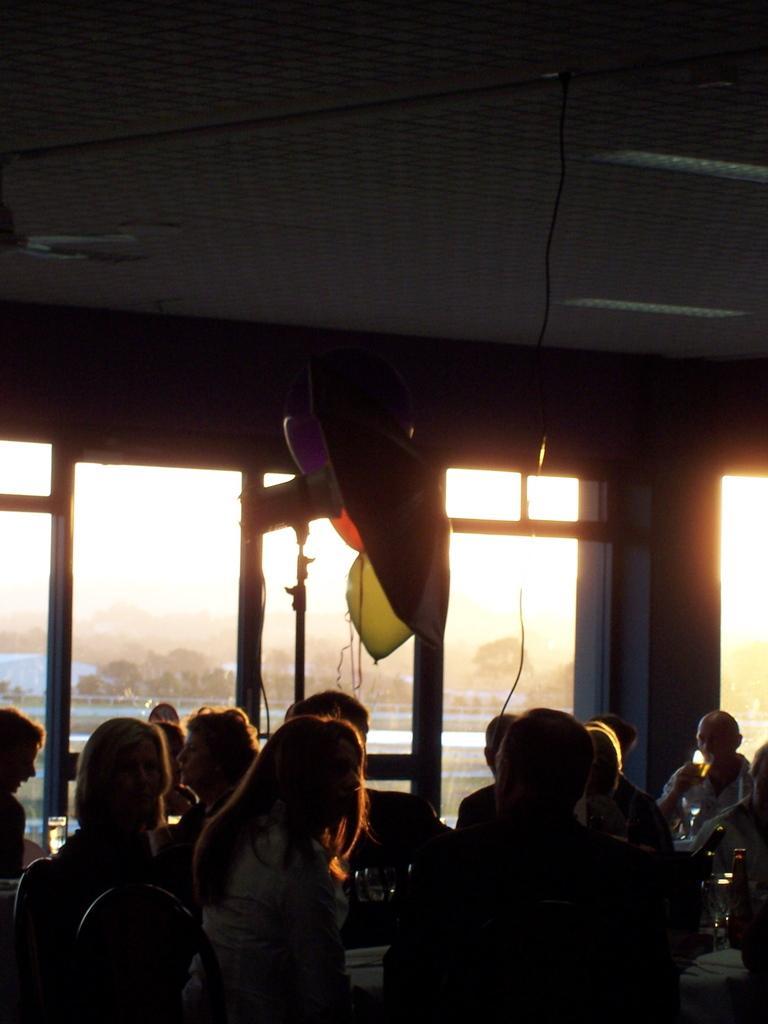How would you summarize this image in a sentence or two? In this picture we can see some a group of people sitting on chairs and a person is holding a glass. Behind the people there are glass windows, wall and an object on the stand. Behind the windows we can see there are trees and the sky. 